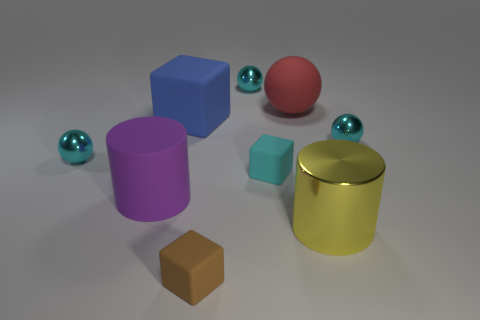Are there fewer purple cylinders that are in front of the purple thing than big cylinders?
Provide a succinct answer. Yes. What is the sphere that is to the left of the tiny cyan shiny object behind the metal thing that is to the right of the yellow thing made of?
Provide a short and direct response. Metal. Is the number of balls in front of the red ball greater than the number of big matte objects that are to the right of the blue matte cube?
Provide a succinct answer. Yes. How many metallic things are small brown objects or large purple spheres?
Provide a short and direct response. 0. There is a object that is on the left side of the big rubber cylinder; what is its material?
Offer a terse response. Metal. What number of things are either tiny brown shiny blocks or tiny cyan things behind the cyan matte object?
Provide a succinct answer. 3. There is a yellow thing that is the same size as the matte cylinder; what shape is it?
Offer a very short reply. Cylinder. Does the object that is behind the red rubber object have the same material as the brown block?
Offer a terse response. No. The large red thing is what shape?
Provide a short and direct response. Sphere. What number of cyan objects are either tiny shiny things or large matte cylinders?
Provide a short and direct response. 3. 